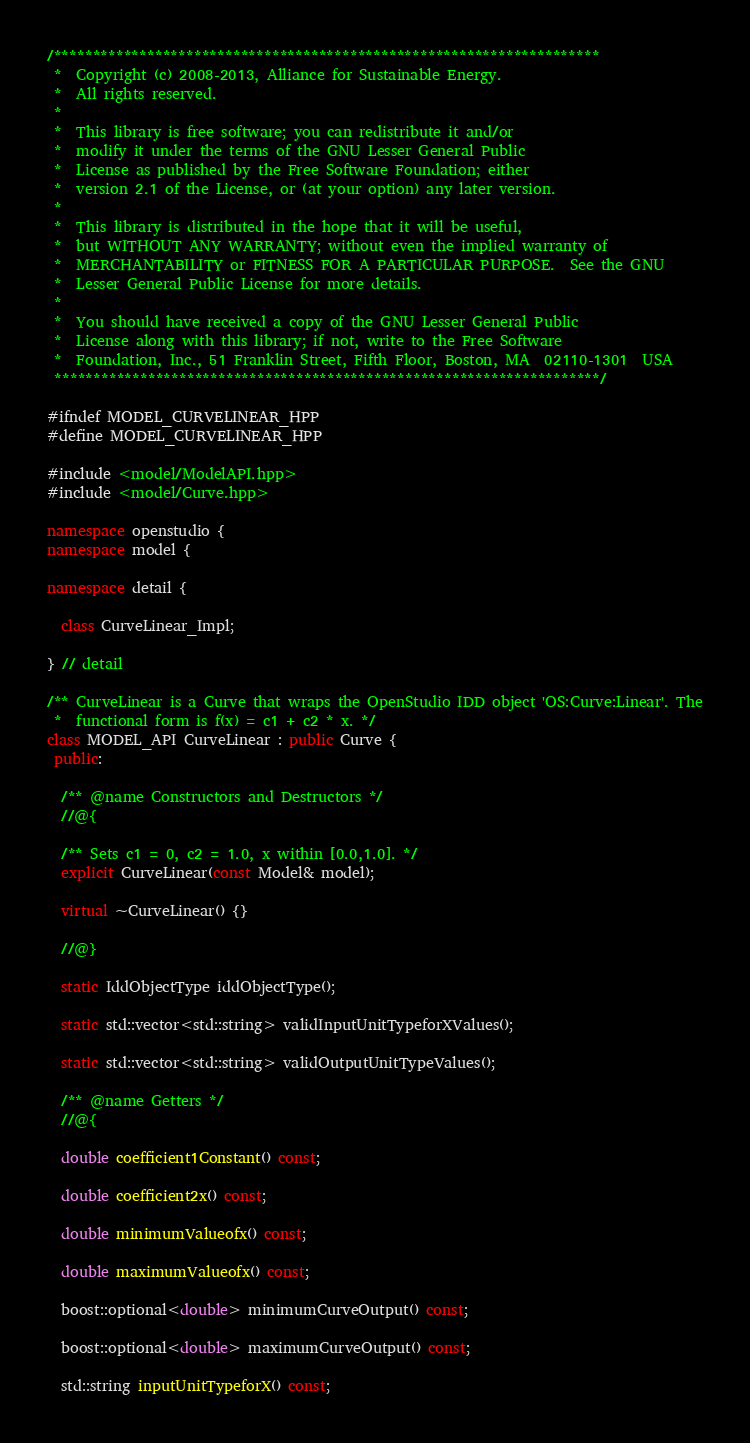<code> <loc_0><loc_0><loc_500><loc_500><_C++_>/**********************************************************************
 *  Copyright (c) 2008-2013, Alliance for Sustainable Energy.
 *  All rights reserved.
 *
 *  This library is free software; you can redistribute it and/or
 *  modify it under the terms of the GNU Lesser General Public
 *  License as published by the Free Software Foundation; either
 *  version 2.1 of the License, or (at your option) any later version.
 *
 *  This library is distributed in the hope that it will be useful,
 *  but WITHOUT ANY WARRANTY; without even the implied warranty of
 *  MERCHANTABILITY or FITNESS FOR A PARTICULAR PURPOSE.  See the GNU
 *  Lesser General Public License for more details.
 *
 *  You should have received a copy of the GNU Lesser General Public
 *  License along with this library; if not, write to the Free Software
 *  Foundation, Inc., 51 Franklin Street, Fifth Floor, Boston, MA  02110-1301  USA
 **********************************************************************/

#ifndef MODEL_CURVELINEAR_HPP
#define MODEL_CURVELINEAR_HPP

#include <model/ModelAPI.hpp>
#include <model/Curve.hpp>

namespace openstudio {
namespace model {

namespace detail {

  class CurveLinear_Impl;

} // detail

/** CurveLinear is a Curve that wraps the OpenStudio IDD object 'OS:Curve:Linear'. The
 *  functional form is f(x) = c1 + c2 * x. */
class MODEL_API CurveLinear : public Curve {
 public:

  /** @name Constructors and Destructors */
  //@{

  /** Sets c1 = 0, c2 = 1.0, x within [0.0,1.0]. */
  explicit CurveLinear(const Model& model);

  virtual ~CurveLinear() {}

  //@}

  static IddObjectType iddObjectType();

  static std::vector<std::string> validInputUnitTypeforXValues();

  static std::vector<std::string> validOutputUnitTypeValues();

  /** @name Getters */
  //@{

  double coefficient1Constant() const;

  double coefficient2x() const;

  double minimumValueofx() const;

  double maximumValueofx() const;

  boost::optional<double> minimumCurveOutput() const;

  boost::optional<double> maximumCurveOutput() const;

  std::string inputUnitTypeforX() const;
</code> 